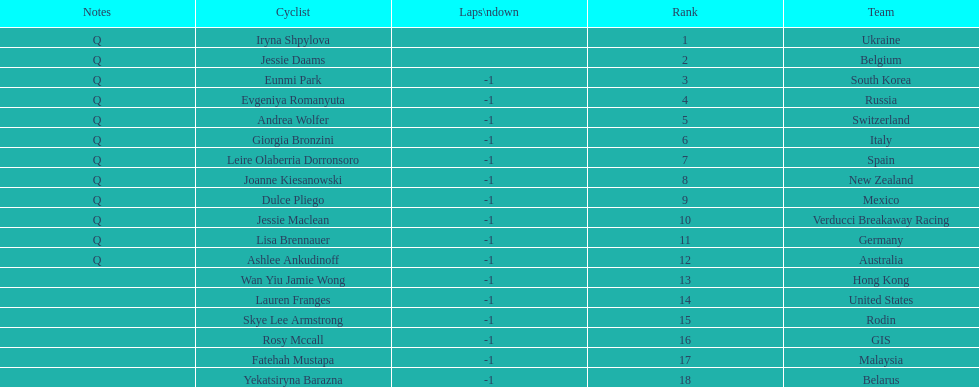What team is listed previous to belgium? Ukraine. 